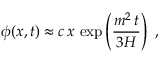<formula> <loc_0><loc_0><loc_500><loc_500>\phi ( x , t ) \approx c \, x \, \exp \left ( { \frac { m ^ { 2 } \, t } { 3 H } } \right ) \ ,</formula> 